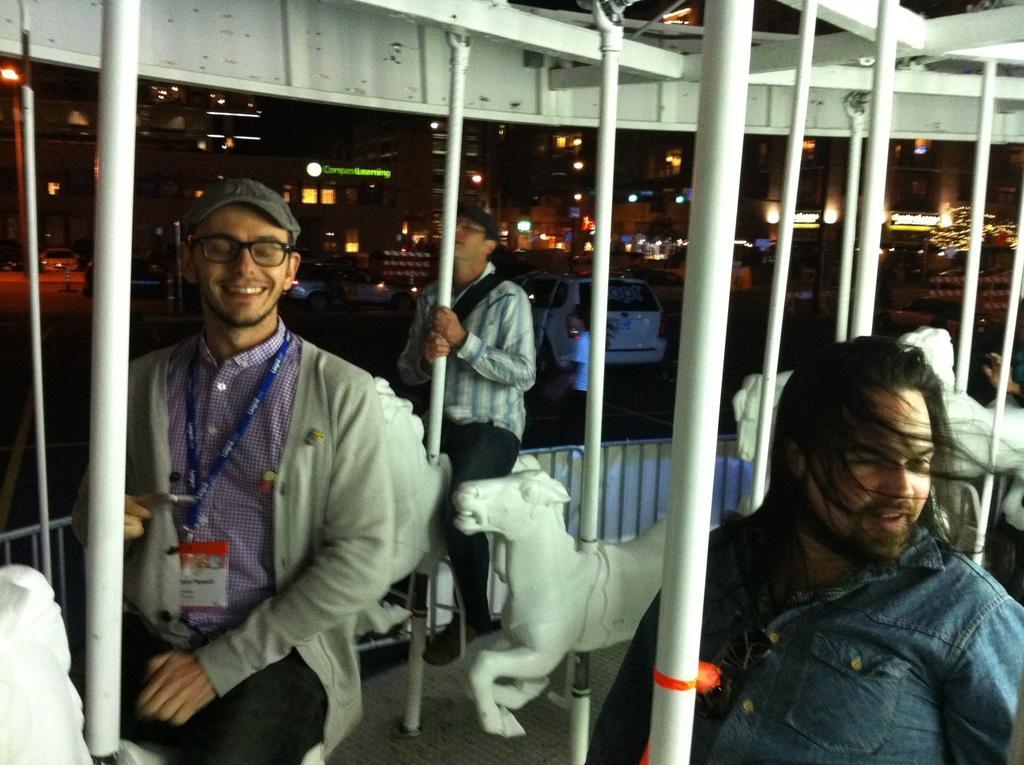Please provide a concise description of this image. In the picture some people are taking the swing ride with dolls and behind them there is a vehicle and around the vehicle there are many other buildings, the image is captured in the night time so the buildings are very bright with the lights. 